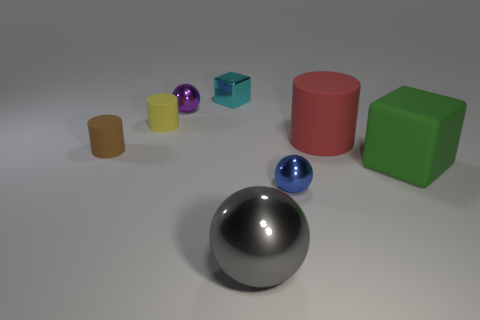Subtract all small rubber cylinders. How many cylinders are left? 1 Subtract all green cubes. How many cubes are left? 1 Subtract all blocks. How many objects are left? 6 Add 7 big purple metal cylinders. How many big purple metal cylinders exist? 7 Add 1 tiny purple balls. How many objects exist? 9 Subtract 1 gray balls. How many objects are left? 7 Subtract 2 cylinders. How many cylinders are left? 1 Subtract all purple spheres. Subtract all red cylinders. How many spheres are left? 2 Subtract all red cubes. How many red cylinders are left? 1 Subtract all purple metallic balls. Subtract all small blue spheres. How many objects are left? 6 